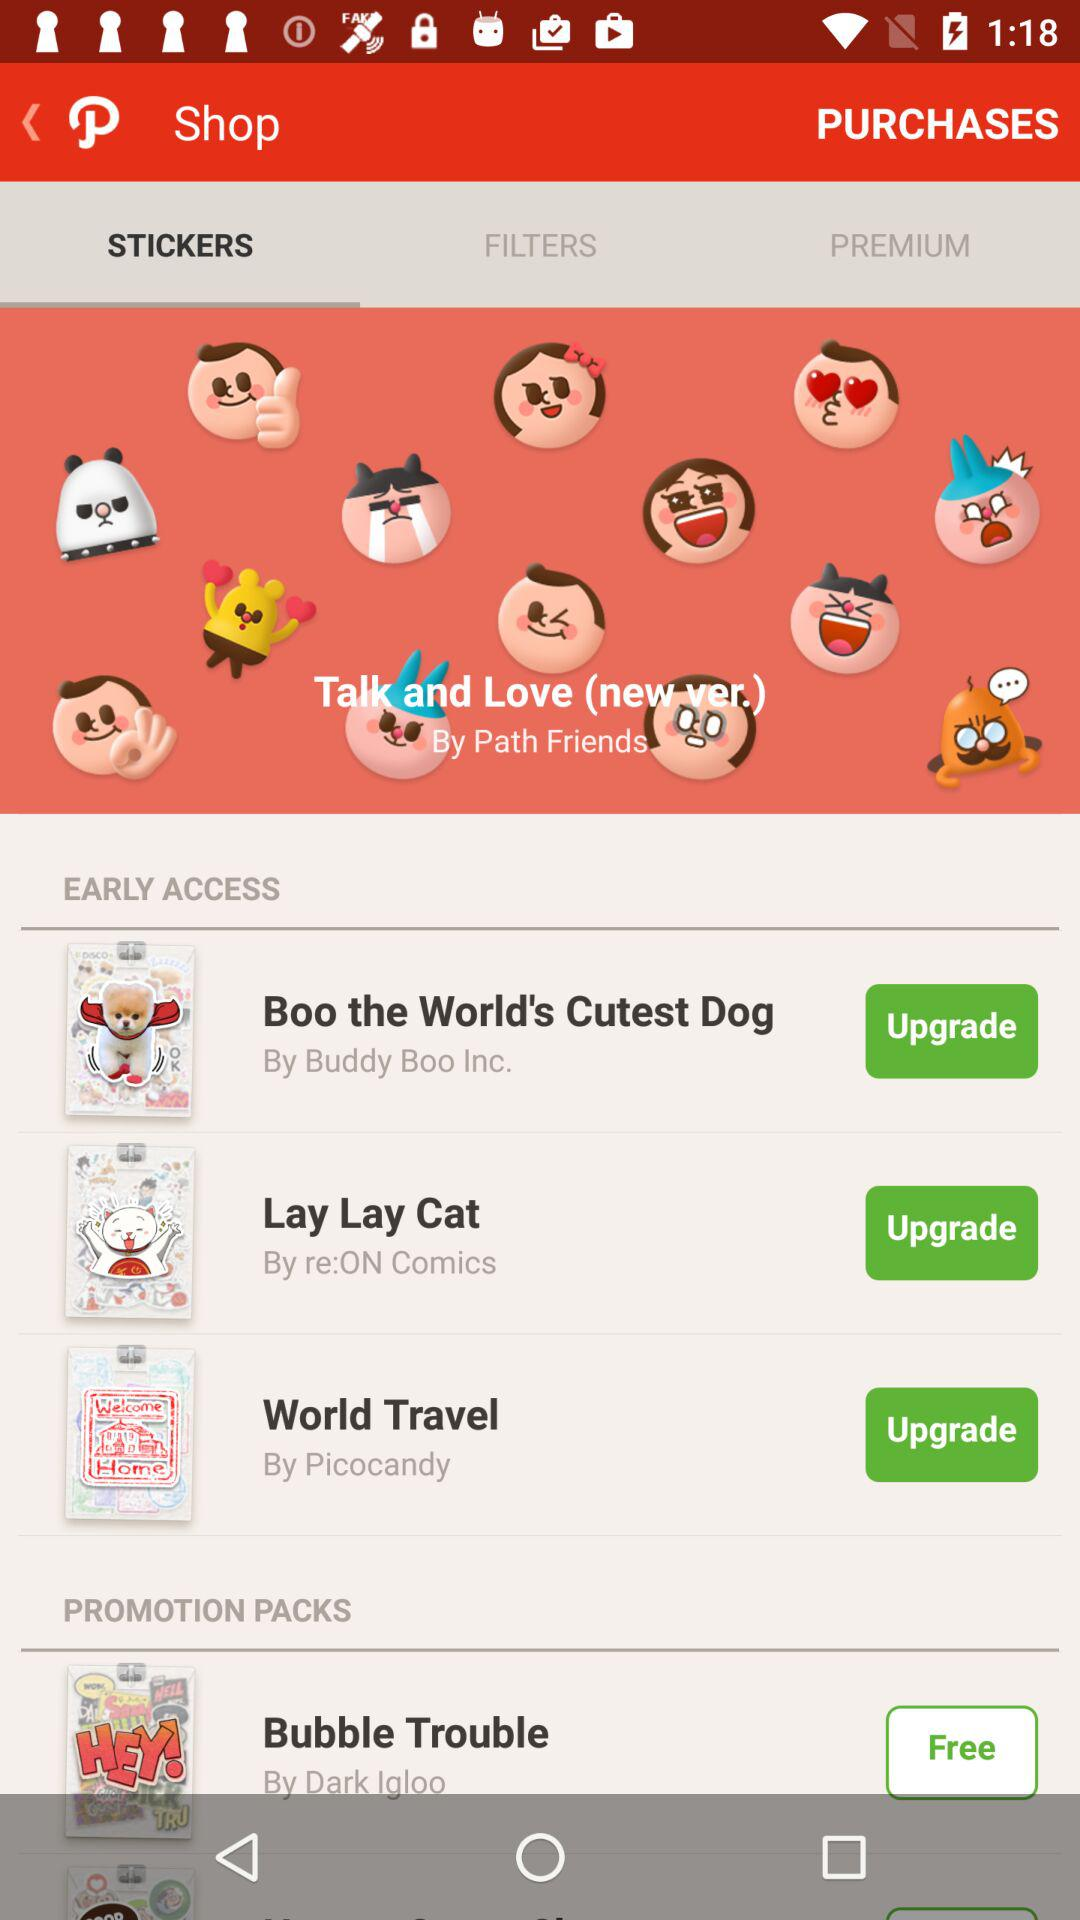By whom Lay Lay Cat stickers were oriented? Lay Lay Cat stickers were oriented by "re:ON Comics". 